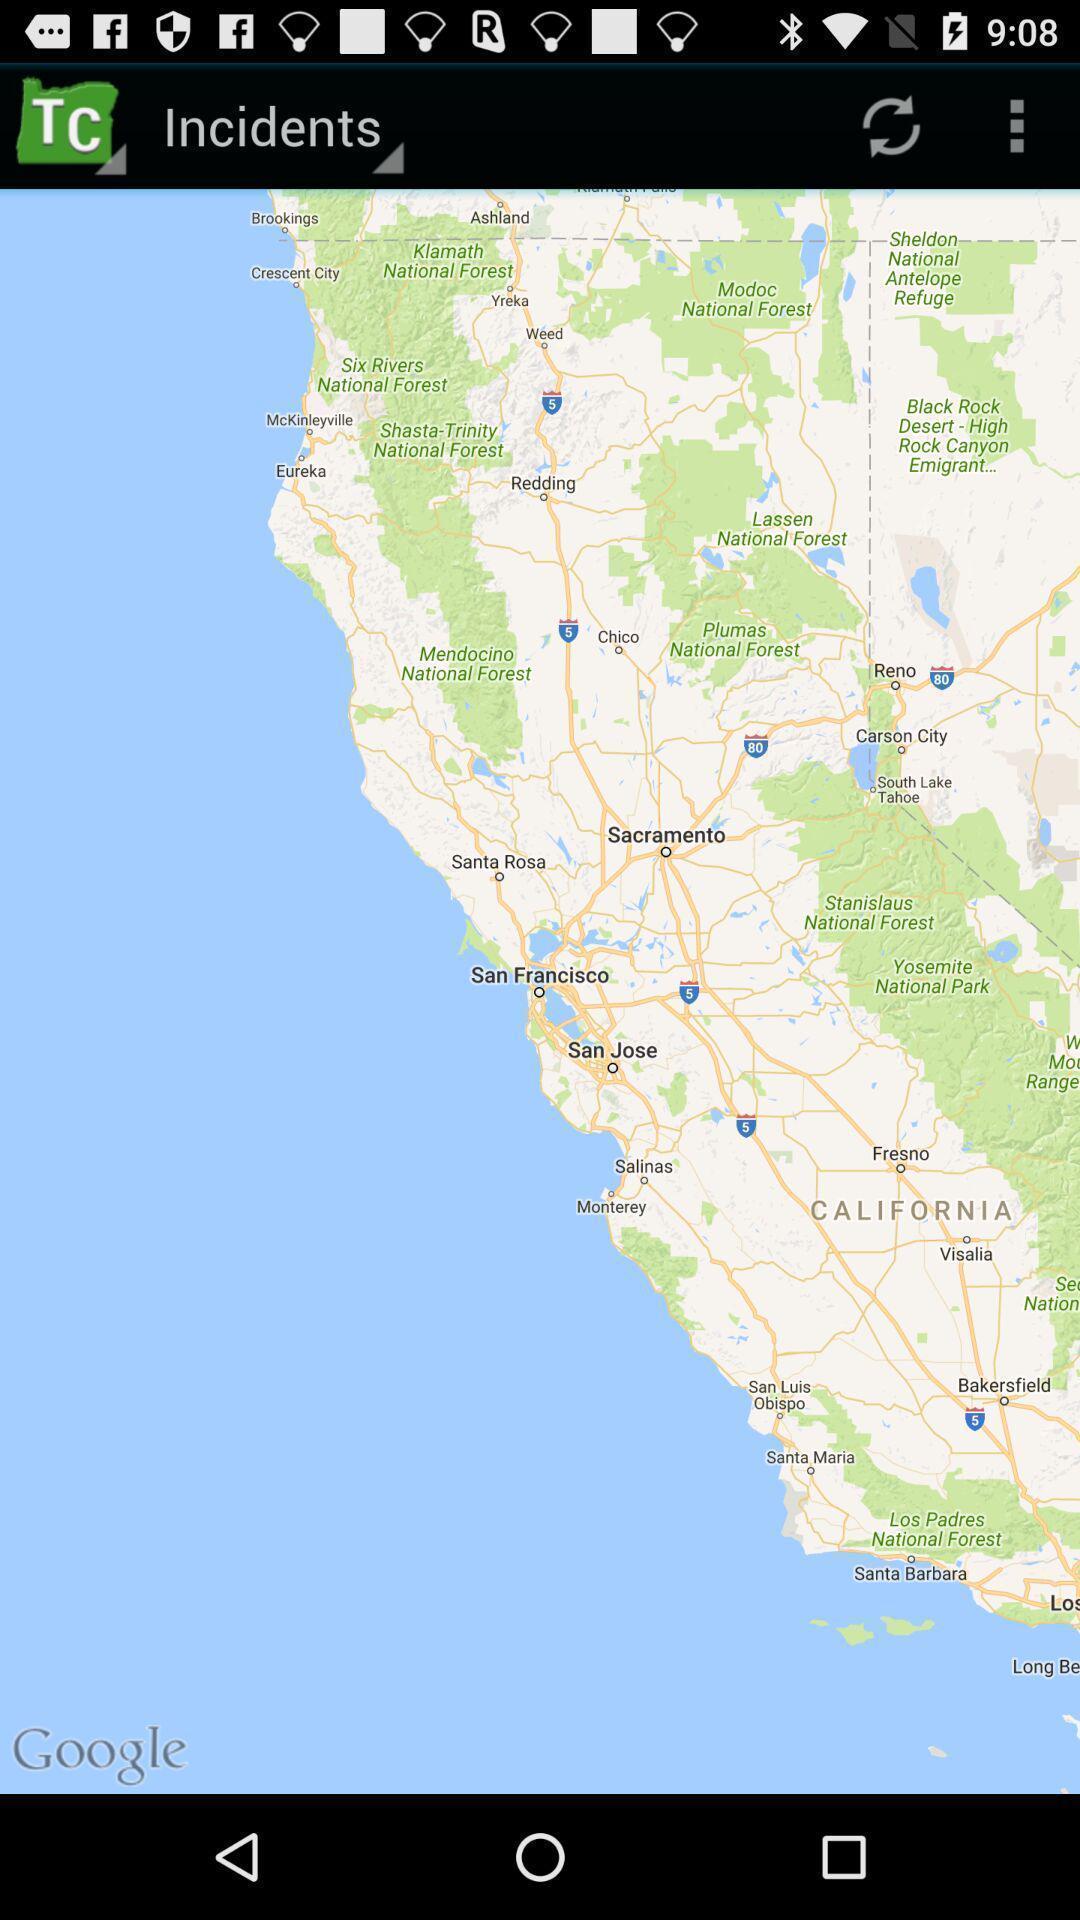Explain what's happening in this screen capture. Screen shows incidents with map view. 